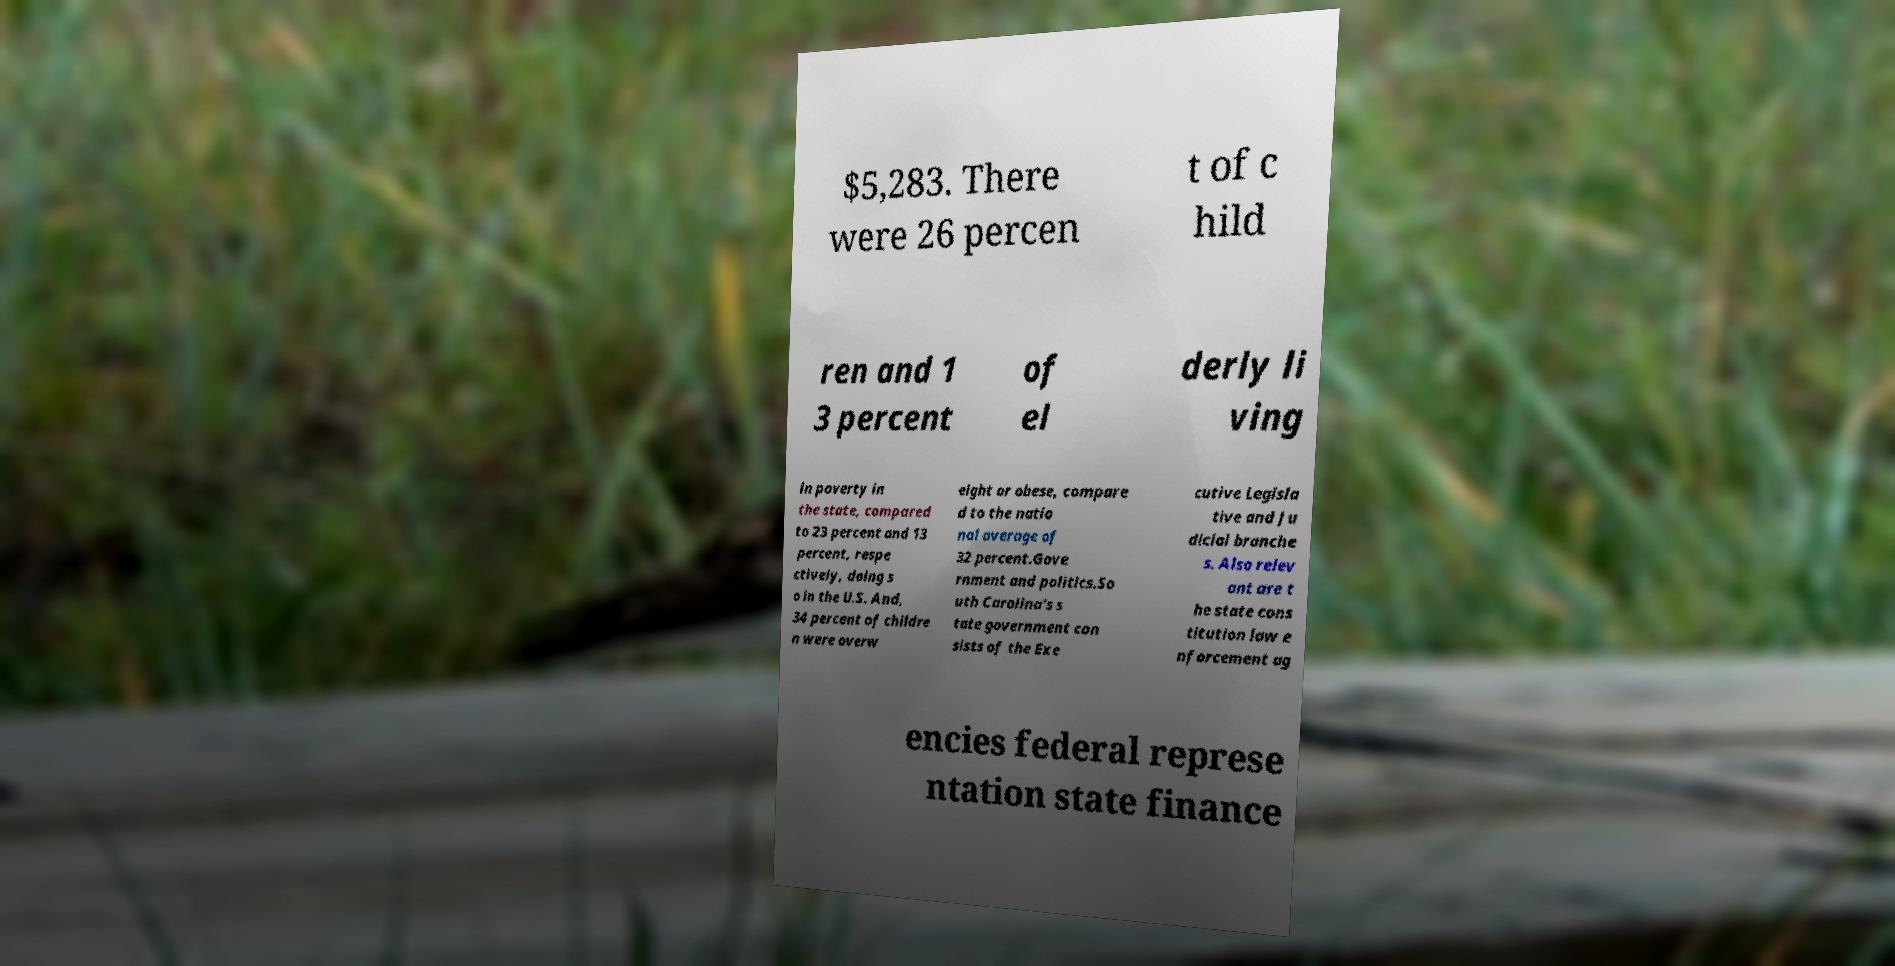Please identify and transcribe the text found in this image. $5,283. There were 26 percen t of c hild ren and 1 3 percent of el derly li ving in poverty in the state, compared to 23 percent and 13 percent, respe ctively, doing s o in the U.S. And, 34 percent of childre n were overw eight or obese, compare d to the natio nal average of 32 percent.Gove rnment and politics.So uth Carolina's s tate government con sists of the Exe cutive Legisla tive and Ju dicial branche s. Also relev ant are t he state cons titution law e nforcement ag encies federal represe ntation state finance 